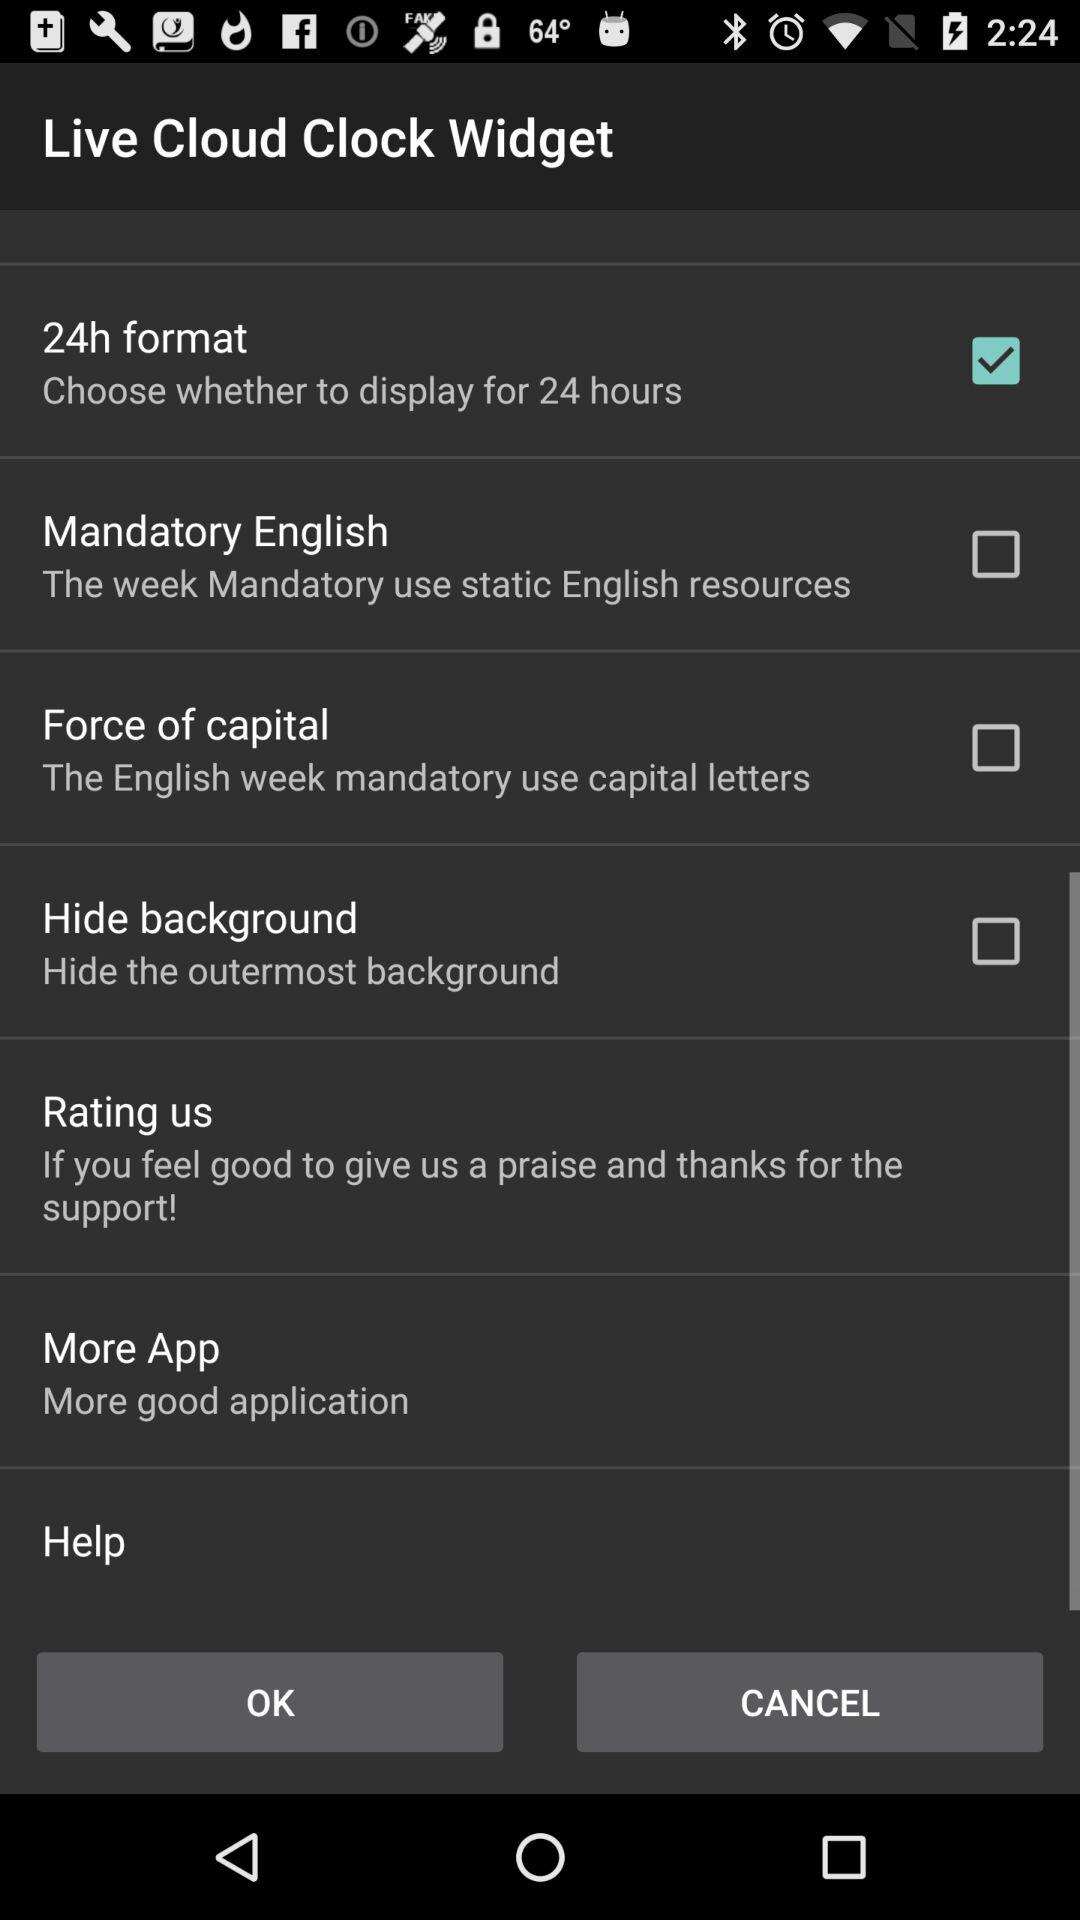What's the status of "24h format"? The status of "24h format" is "on". 